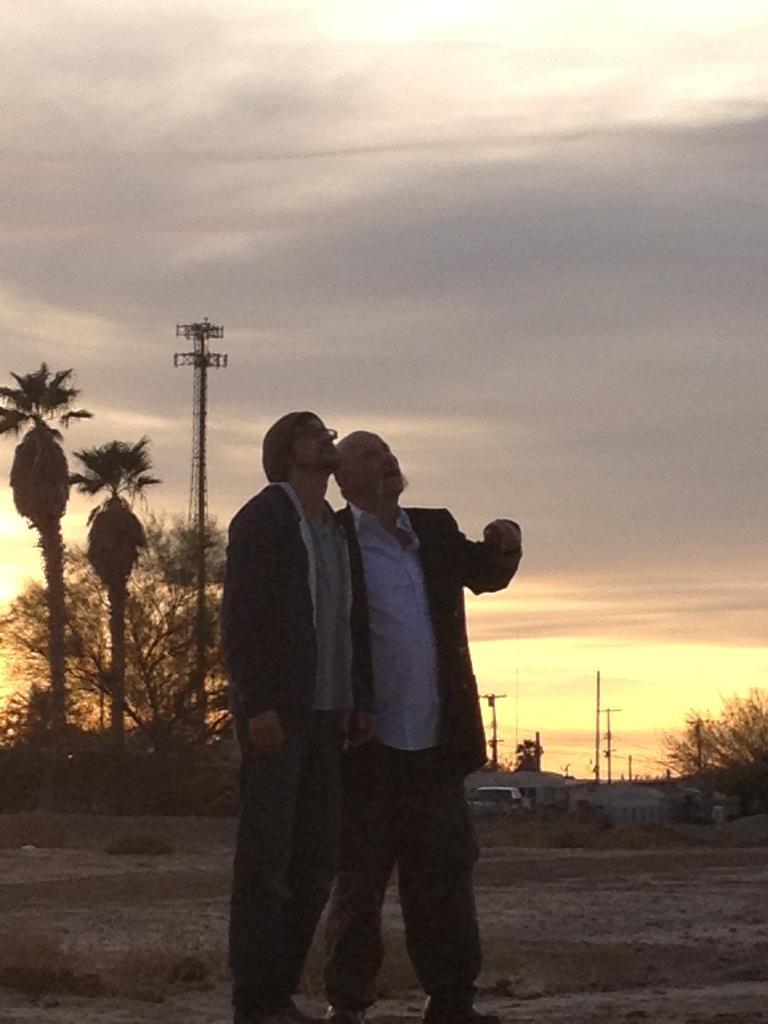How would you summarize this image in a sentence or two? This image is taken outdoors. At the top of the image there is the sky with clouds. At the bottom of the image there is a ground with grass on it. In the background there are a few trees and plants on the ground and there are a few poles and there is a tower. A vehicle is parked on the ground. In the middle of the image two men are standing on the ground. 